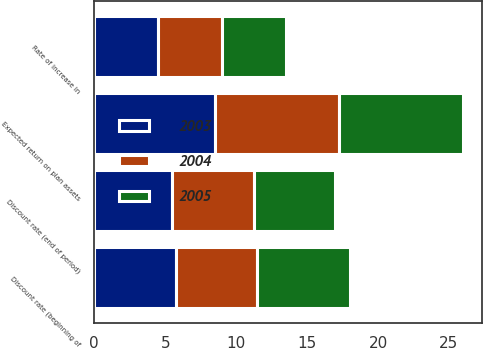<chart> <loc_0><loc_0><loc_500><loc_500><stacked_bar_chart><ecel><fcel>Discount rate (beginning of<fcel>Discount rate (end of period)<fcel>Rate of increase in<fcel>Expected return on plan assets<nl><fcel>2003<fcel>5.75<fcel>5.5<fcel>4.5<fcel>8.5<nl><fcel>2004<fcel>5.75<fcel>5.75<fcel>4.5<fcel>8.75<nl><fcel>2005<fcel>6.5<fcel>5.75<fcel>4.5<fcel>8.75<nl></chart> 